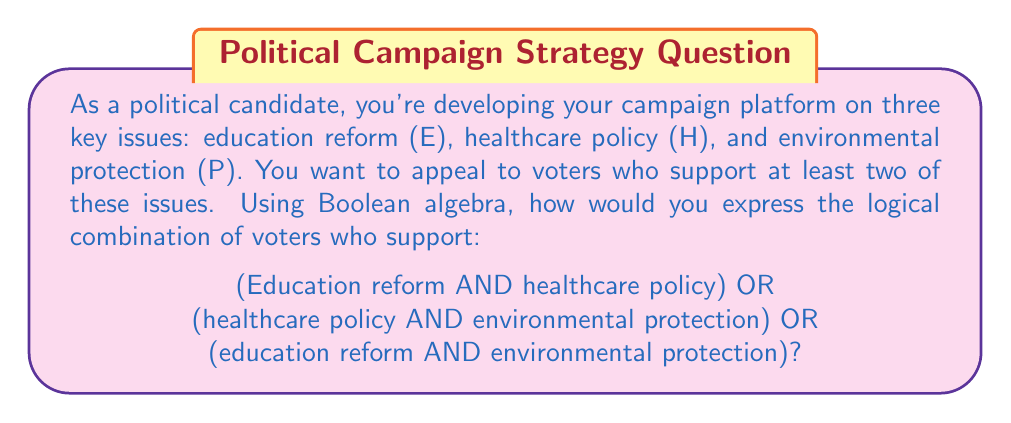Can you answer this question? Let's approach this step-by-step using Boolean algebra:

1) First, let's define our variables:
   E: Education reform
   H: Healthcare policy
   P: Environmental protection

2) Now, we need to express each combination:
   - Education reform AND healthcare policy: $E \cdot H$
   - Healthcare policy AND environmental protection: $H \cdot P$
   - Education reform AND environmental protection: $E \cdot P$

3) We want voters who support at least one of these combinations, so we use the OR operator (represented by +) to combine them:

   $(E \cdot H) + (H \cdot P) + (E \cdot P)$

4) This expression represents the logical combination we're looking for. However, we can simplify it further using the distributive law of Boolean algebra:

   $E \cdot H + H \cdot P + E \cdot P$
   $= H \cdot (E + P) + E \cdot P$
   $= H \cdot E + H \cdot P + E \cdot P$

5) This simplified form is equivalent to our original expression and represents the same group of voters.

As a political candidate, this Boolean expression helps you target voters who support at least two of your three key policy positions, allowing you to craft messages that resonate with these overlapping interest groups.
Answer: $H \cdot (E + P) + E \cdot P$ 